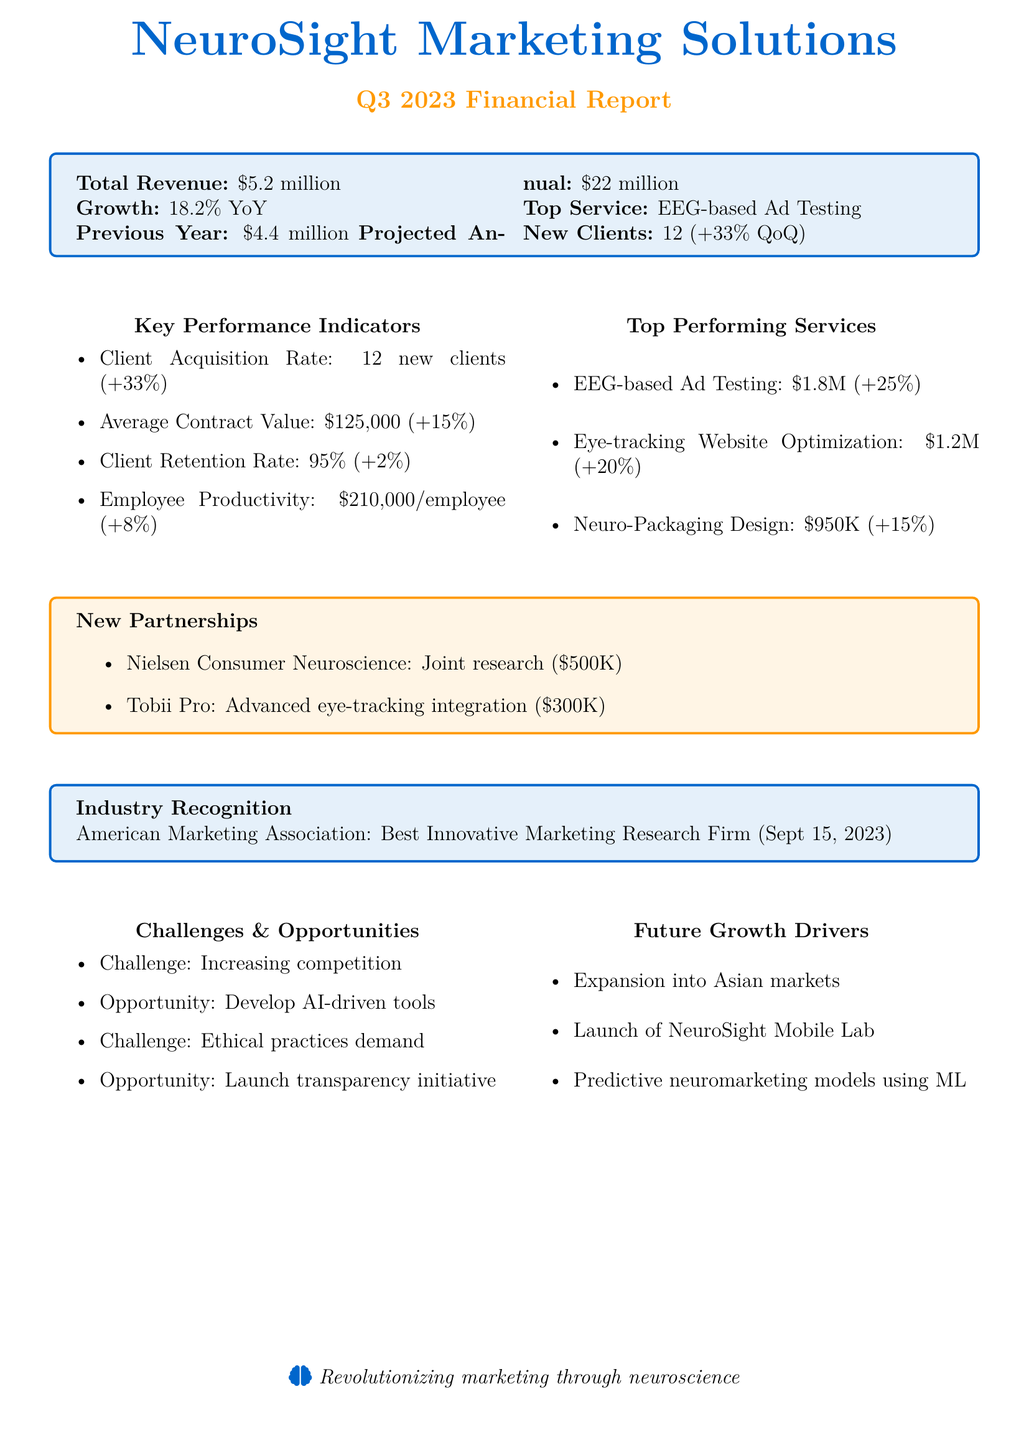what is the total revenue for Q3 2023? The total revenue is clearly stated in the document as $5.2 million for Q3 2023.
Answer: $5.2 million what was the revenue growth percentage compared to the previous year? The growth percentage indicates the increase from the previous year's revenue, which is reported as 18.2%.
Answer: 18.2% how many new clients were acquired this quarter? The document lists the client acquisition rate which shows there were 12 new clients acquired in Q3 2023.
Answer: 12 new clients what is the average contract value? The average contract value is mentioned in the key performance indicators as $125,000.
Answer: $125,000 which service generated the highest revenue this quarter? The document indicates that EEG-based Ad Testing is the top-performing service generating $1.8 million.
Answer: EEG-based Ad Testing what challenge is identified in neuromarketing? The document mentions increasing competition in the neuromarketing space as one of the challenges.
Answer: Increasing competition what project is associated with Nielsen Consumer Neuroscience? The document states that they are involved in a joint research project on cross-cultural neuromarketing worth $500,000.
Answer: Joint research on cross-cultural neuromarketing when did the American Marketing Association recognize the firm? The recognition date is provided in the document as September 15, 2023.
Answer: September 15, 2023 what is the projected annual revenue? The projected annual revenue for NeuroSight Marketing Solutions is stated as $22 million.
Answer: $22 million 